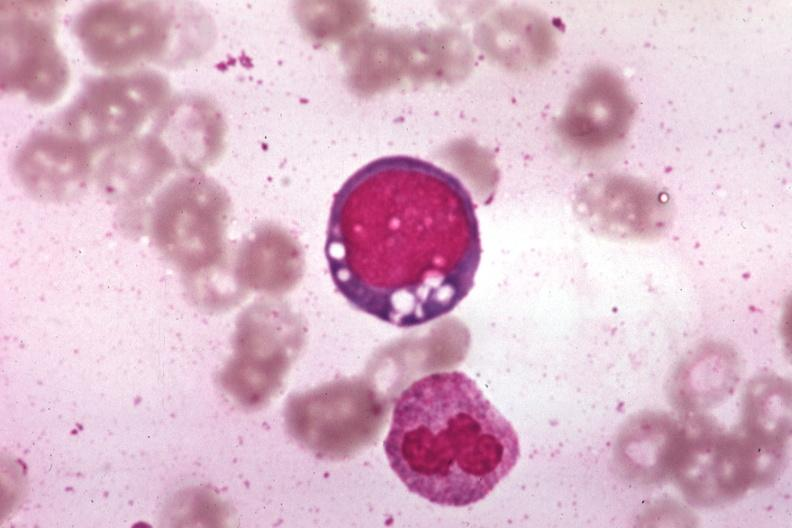how is wrights vacuolated erythroblast source?
Answer the question using a single word or phrase. Unknown 